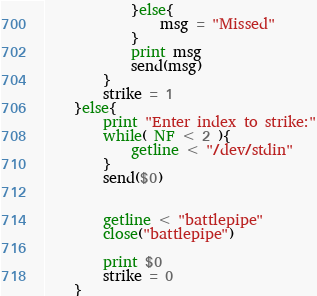<code> <loc_0><loc_0><loc_500><loc_500><_Awk_>			}else{
				msg = "Missed"
			}
			print msg
			send(msg)
		}
		strike = 1
	}else{
		print "Enter index to strike:"
		while( NF < 2 ){
			getline < "/dev/stdin"
		}
		send($0)


		getline < "battlepipe"
		close("battlepipe")

		print $0
		strike = 0
	}</code> 